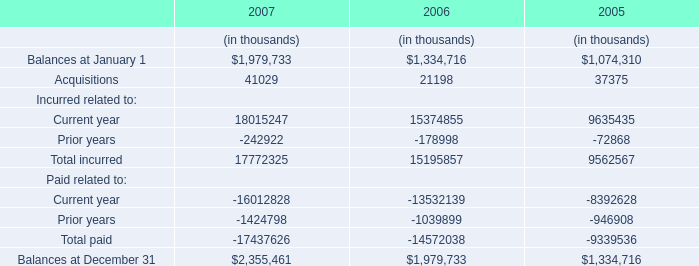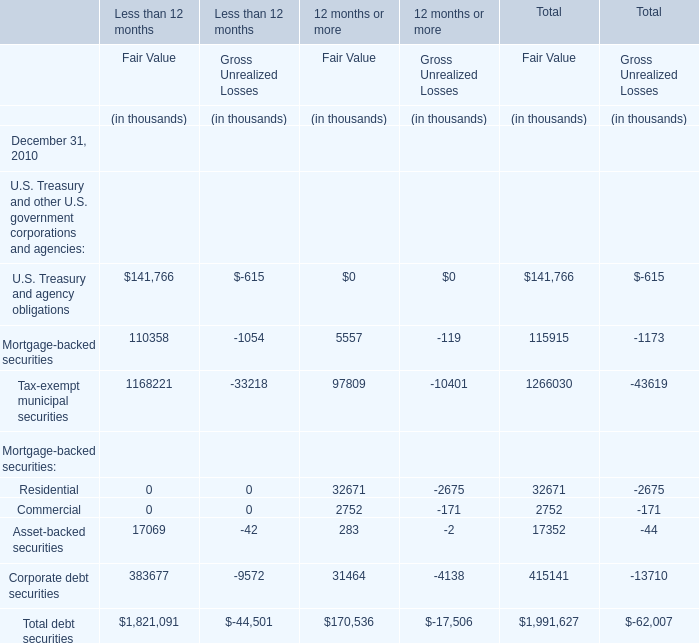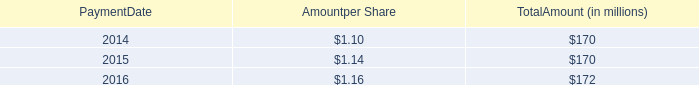What is the average value of Total debt securities for Less than 12 months, 12 months or more, and Total in terms of Fair Value? (in thousand) 
Computations: (((1821091 + 170536) + 1991627) / 3)
Answer: 1327751.33333. 